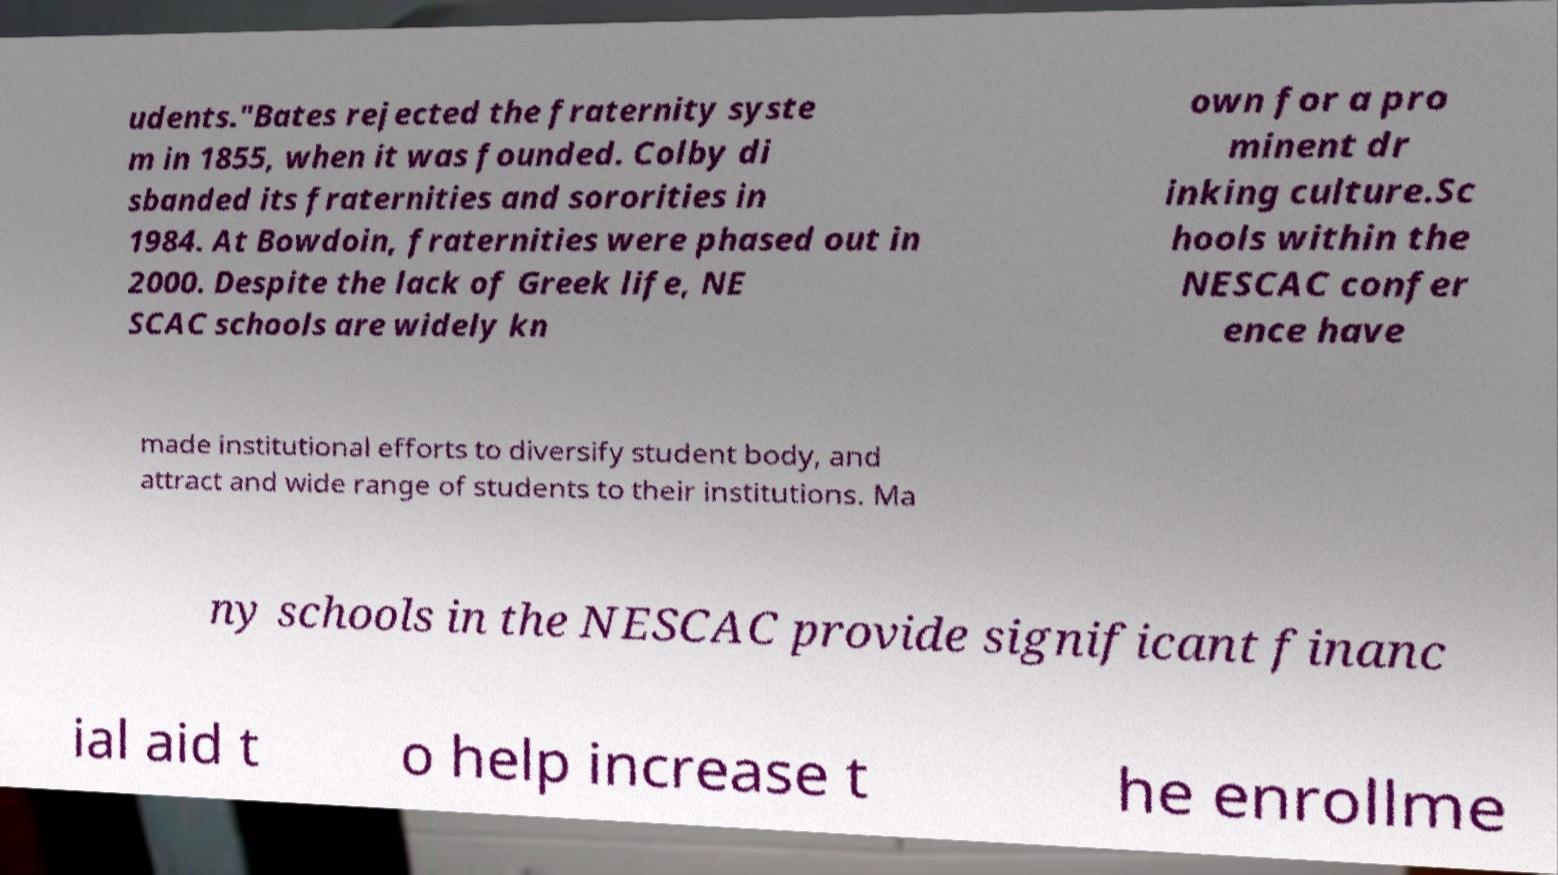Could you assist in decoding the text presented in this image and type it out clearly? udents."Bates rejected the fraternity syste m in 1855, when it was founded. Colby di sbanded its fraternities and sororities in 1984. At Bowdoin, fraternities were phased out in 2000. Despite the lack of Greek life, NE SCAC schools are widely kn own for a pro minent dr inking culture.Sc hools within the NESCAC confer ence have made institutional efforts to diversify student body, and attract and wide range of students to their institutions. Ma ny schools in the NESCAC provide significant financ ial aid t o help increase t he enrollme 